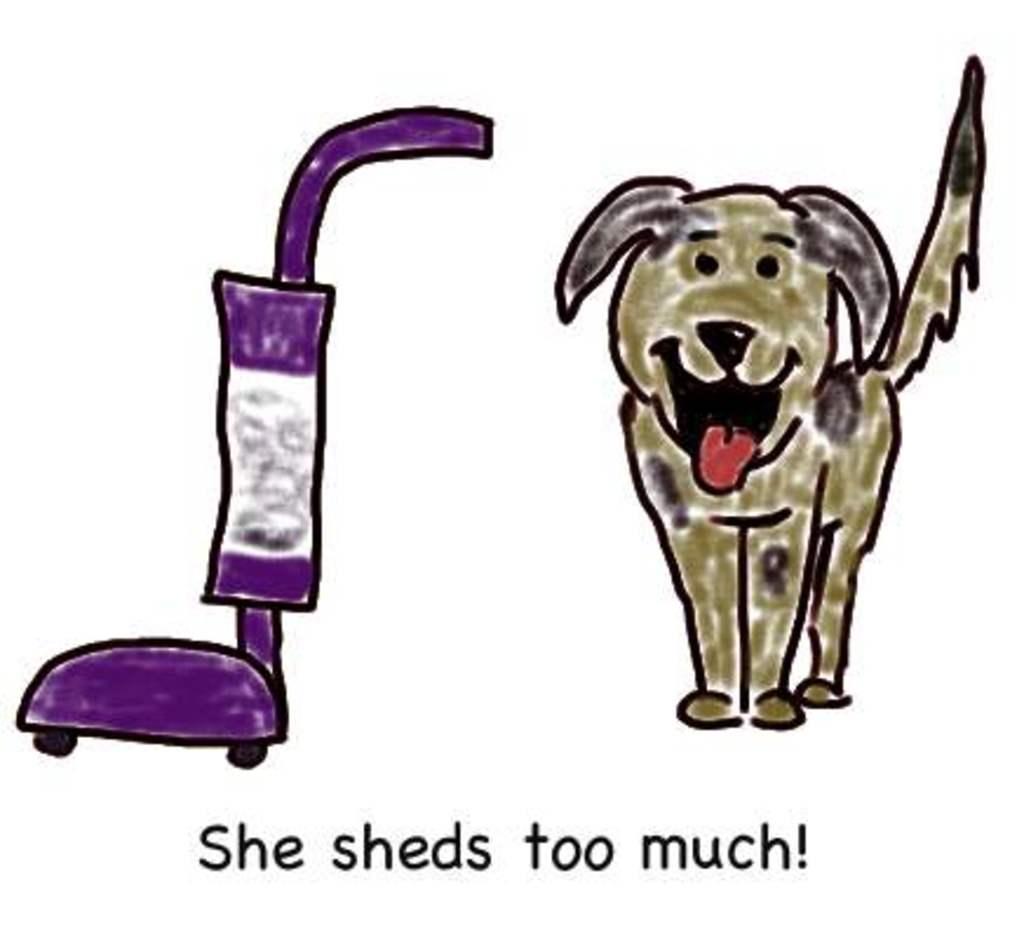Could you give a brief overview of what you see in this image? In this image I can see depiction picture where I can see a vacuum cleaner and a dog. I can see colour of this vacuum cleaner is purple and white. I can see colour of this dog is black and green. Bottom of this picture I can see something is written. 